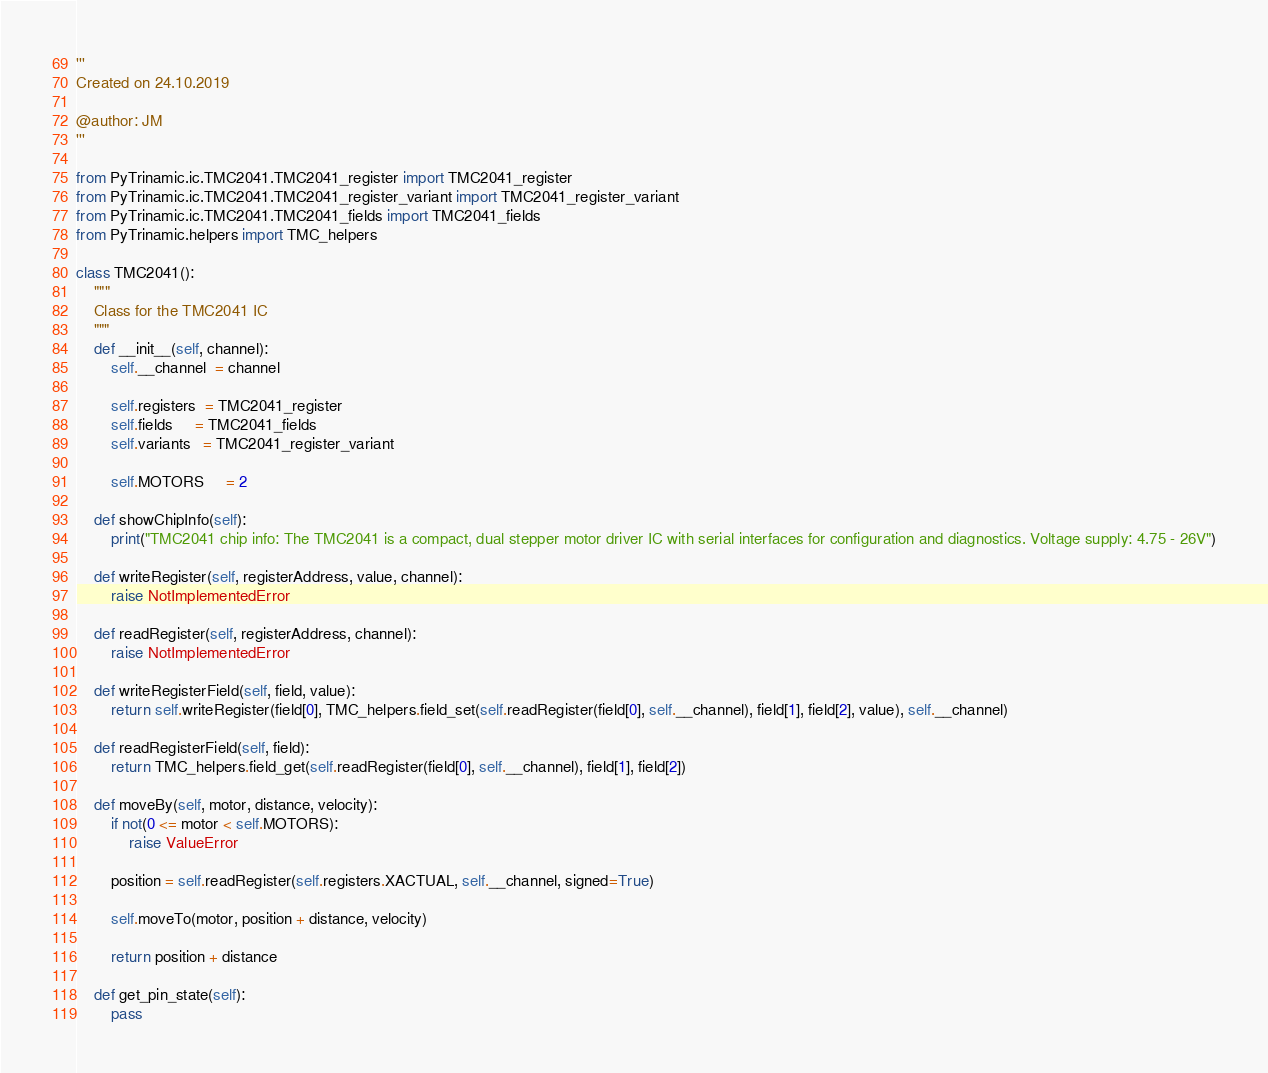Convert code to text. <code><loc_0><loc_0><loc_500><loc_500><_Python_>'''
Created on 24.10.2019

@author: JM
'''

from PyTrinamic.ic.TMC2041.TMC2041_register import TMC2041_register
from PyTrinamic.ic.TMC2041.TMC2041_register_variant import TMC2041_register_variant
from PyTrinamic.ic.TMC2041.TMC2041_fields import TMC2041_fields
from PyTrinamic.helpers import TMC_helpers

class TMC2041():
    """
    Class for the TMC2041 IC
    """
    def __init__(self, channel):
        self.__channel  = channel

        self.registers  = TMC2041_register
        self.fields     = TMC2041_fields
        self.variants   = TMC2041_register_variant

        self.MOTORS     = 2

    def showChipInfo(self):
        print("TMC2041 chip info: The TMC2041 is a compact, dual stepper motor driver IC with serial interfaces for configuration and diagnostics. Voltage supply: 4.75 - 26V")

    def writeRegister(self, registerAddress, value, channel):
        raise NotImplementedError

    def readRegister(self, registerAddress, channel):
        raise NotImplementedError

    def writeRegisterField(self, field, value):
        return self.writeRegister(field[0], TMC_helpers.field_set(self.readRegister(field[0], self.__channel), field[1], field[2], value), self.__channel)

    def readRegisterField(self, field):
        return TMC_helpers.field_get(self.readRegister(field[0], self.__channel), field[1], field[2])

    def moveBy(self, motor, distance, velocity):
        if not(0 <= motor < self.MOTORS):
            raise ValueError

        position = self.readRegister(self.registers.XACTUAL, self.__channel, signed=True)

        self.moveTo(motor, position + distance, velocity)

        return position + distance

    def get_pin_state(self):
        pass
</code> 